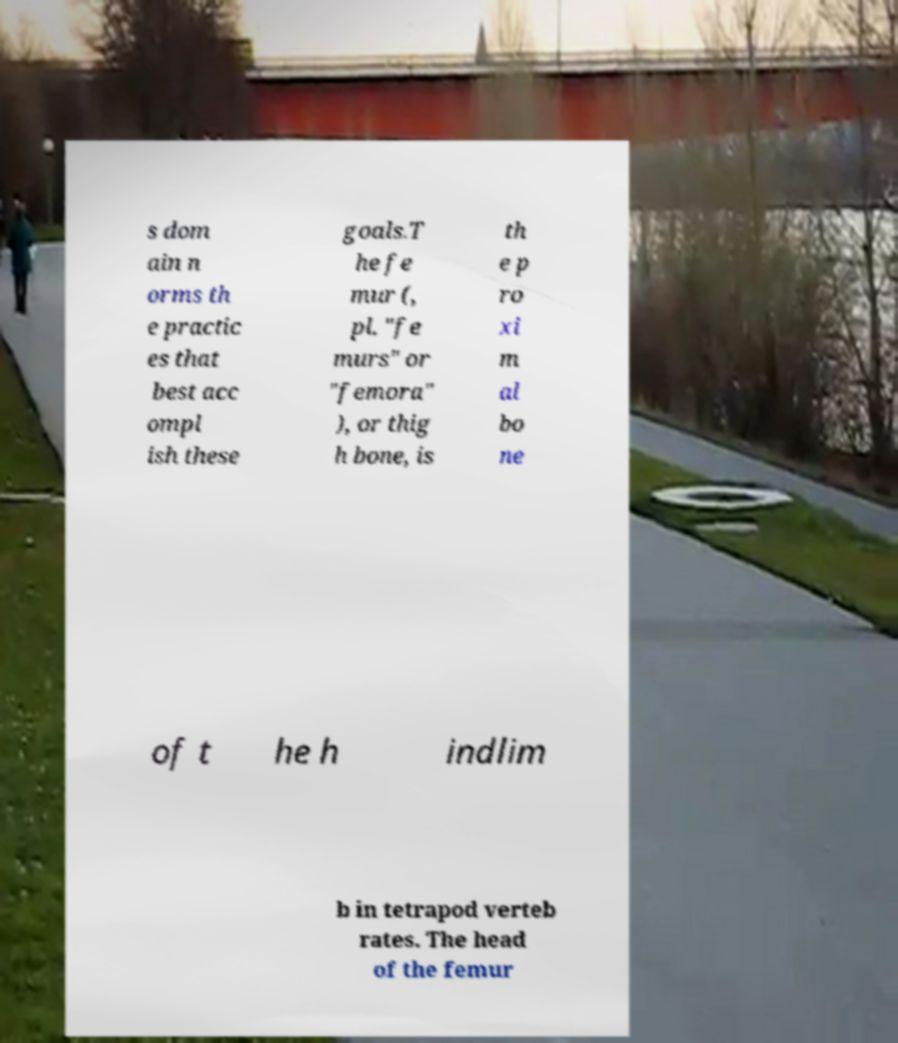There's text embedded in this image that I need extracted. Can you transcribe it verbatim? s dom ain n orms th e practic es that best acc ompl ish these goals.T he fe mur (, pl. "fe murs" or "femora" ), or thig h bone, is th e p ro xi m al bo ne of t he h indlim b in tetrapod verteb rates. The head of the femur 